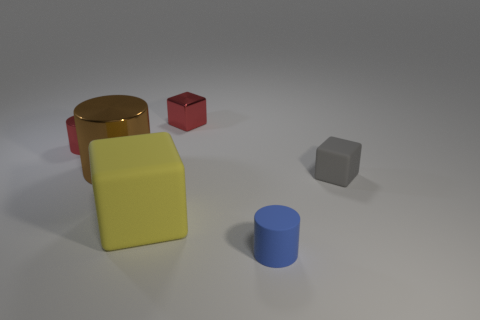Subtract all tiny cubes. How many cubes are left? 1 Add 1 yellow rubber things. How many objects exist? 7 Subtract all brown cylinders. How many cylinders are left? 2 Subtract all purple cubes. Subtract all gray balls. How many cubes are left? 3 Subtract all brown metal cubes. Subtract all gray objects. How many objects are left? 5 Add 5 large rubber objects. How many large rubber objects are left? 6 Add 4 large yellow things. How many large yellow things exist? 5 Subtract 0 cyan cubes. How many objects are left? 6 Subtract 2 cubes. How many cubes are left? 1 